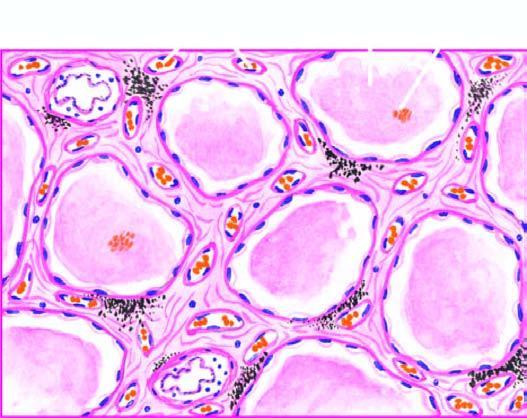do the alveolar spaces as well as interstitium contain eosinophilic, granular, homogeneous and pink proteinaceous oedema fluid along with some rbcs and inflammatory cells?
Answer the question using a single word or phrase. Yes 